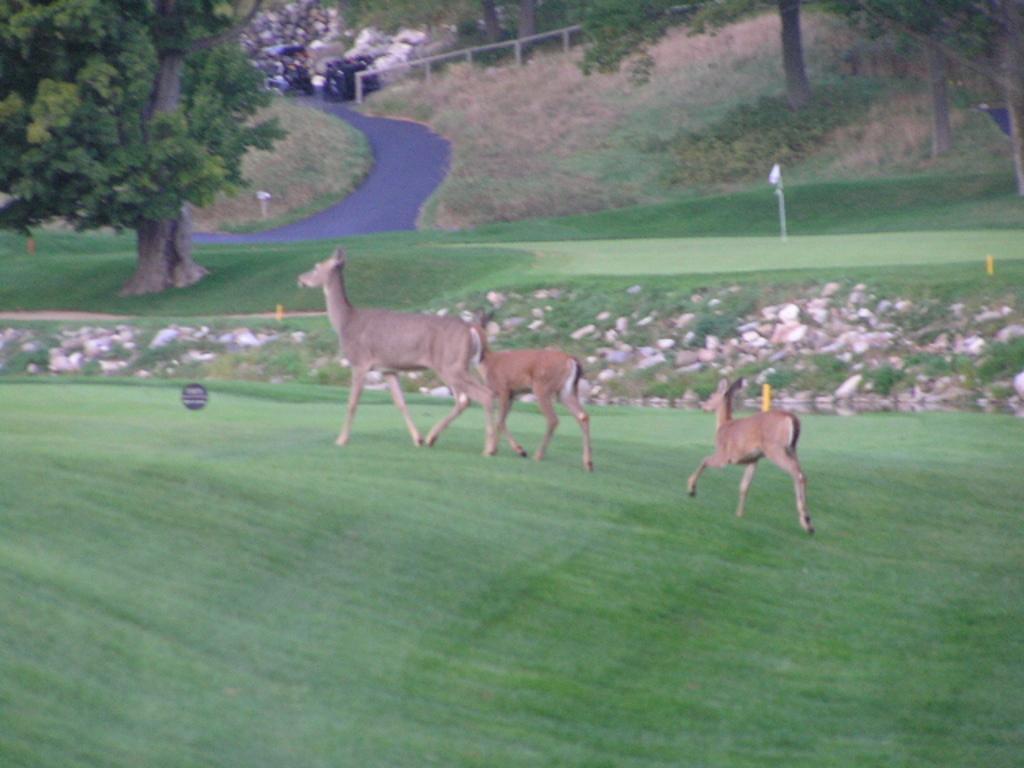How would you summarize this image in a sentence or two? In this image there are animals in the center there is grass on the ground and there are trees and the image is an edited and graphical image. 